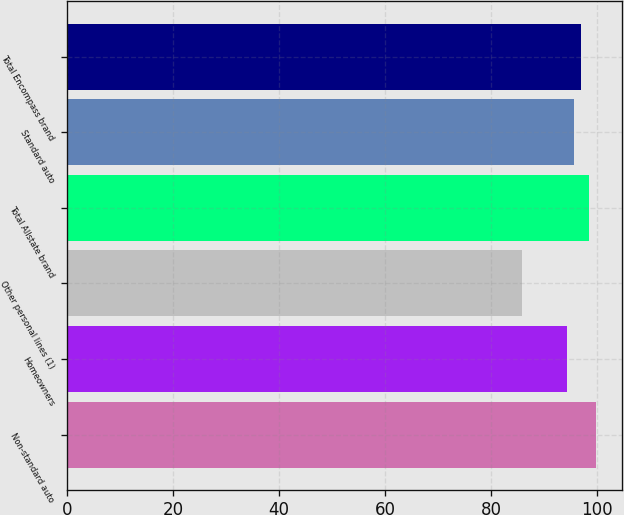Convert chart. <chart><loc_0><loc_0><loc_500><loc_500><bar_chart><fcel>Non-standard auto<fcel>Homeowners<fcel>Other personal lines (1)<fcel>Total Allstate brand<fcel>Standard auto<fcel>Total Encompass brand<nl><fcel>99.8<fcel>94.4<fcel>85.9<fcel>98.45<fcel>95.75<fcel>97.1<nl></chart> 